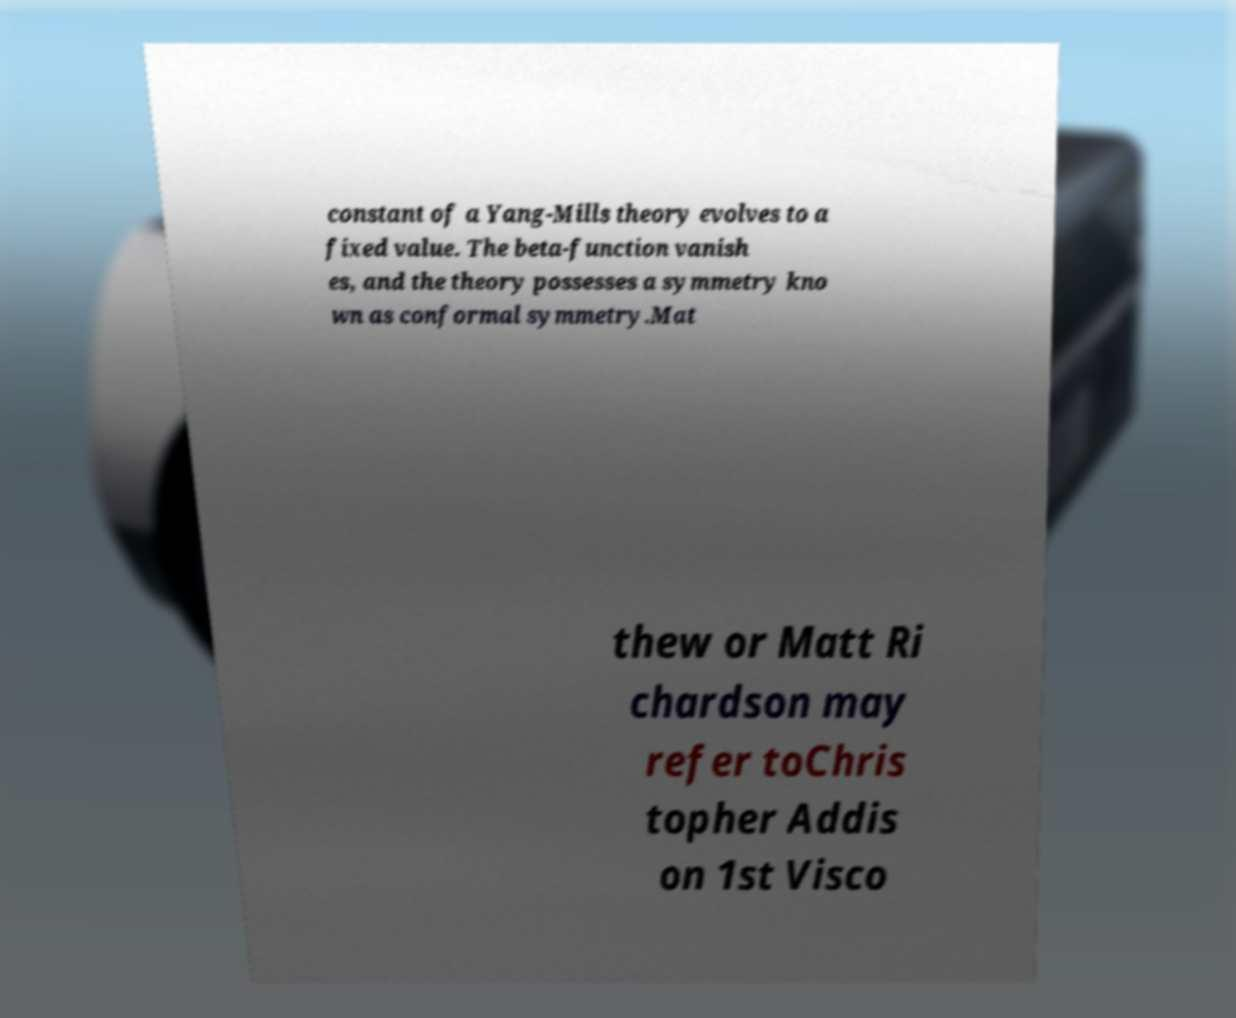Please identify and transcribe the text found in this image. constant of a Yang-Mills theory evolves to a fixed value. The beta-function vanish es, and the theory possesses a symmetry kno wn as conformal symmetry.Mat thew or Matt Ri chardson may refer toChris topher Addis on 1st Visco 